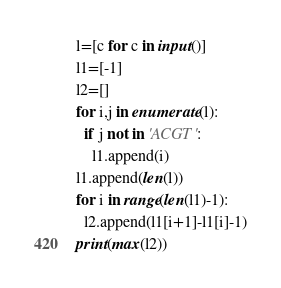Convert code to text. <code><loc_0><loc_0><loc_500><loc_500><_Python_>l=[c for c in input()]
l1=[-1]
l2=[]
for i,j in enumerate(l):
  if j not in 'ACGT':
    l1.append(i)
l1.append(len(l))
for i in range(len(l1)-1):
  l2.append(l1[i+1]-l1[i]-1)
print(max(l2))</code> 